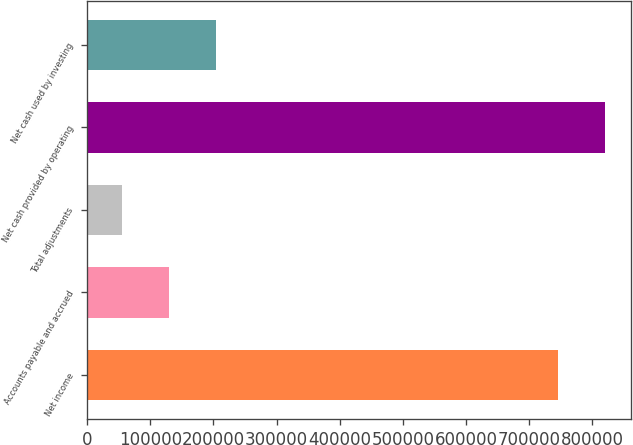Convert chart to OTSL. <chart><loc_0><loc_0><loc_500><loc_500><bar_chart><fcel>Net income<fcel>Accounts payable and accrued<fcel>Total adjustments<fcel>Net cash provided by operating<fcel>Net cash used by investing<nl><fcel>745077<fcel>129432<fcel>54924<fcel>819585<fcel>203939<nl></chart> 